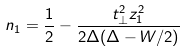Convert formula to latex. <formula><loc_0><loc_0><loc_500><loc_500>n _ { 1 } = \frac { 1 } { 2 } - \frac { t _ { \perp } ^ { 2 } z _ { 1 } ^ { 2 } } { 2 \Delta ( \Delta - W / 2 ) }</formula> 